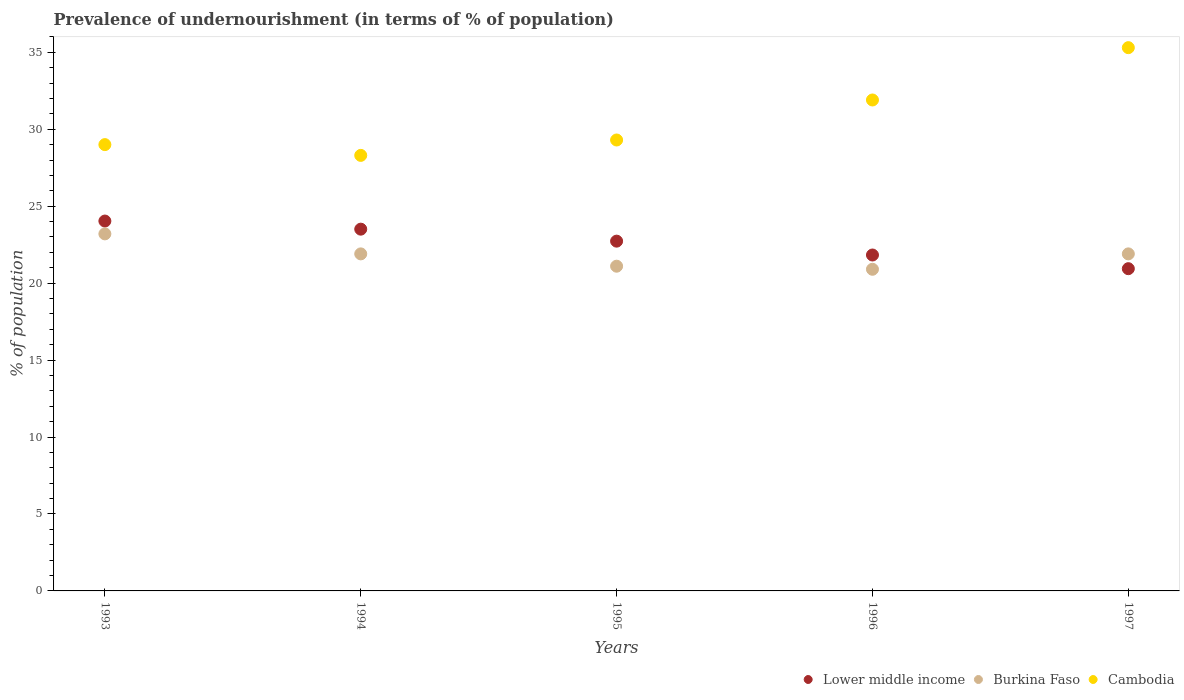Is the number of dotlines equal to the number of legend labels?
Your response must be concise. Yes. What is the percentage of undernourished population in Cambodia in 1995?
Offer a terse response. 29.3. Across all years, what is the maximum percentage of undernourished population in Burkina Faso?
Provide a short and direct response. 23.2. Across all years, what is the minimum percentage of undernourished population in Cambodia?
Keep it short and to the point. 28.3. In which year was the percentage of undernourished population in Cambodia maximum?
Give a very brief answer. 1997. In which year was the percentage of undernourished population in Lower middle income minimum?
Offer a terse response. 1997. What is the total percentage of undernourished population in Burkina Faso in the graph?
Provide a succinct answer. 109. What is the difference between the percentage of undernourished population in Burkina Faso in 1993 and that in 1996?
Ensure brevity in your answer.  2.3. What is the difference between the percentage of undernourished population in Burkina Faso in 1995 and the percentage of undernourished population in Lower middle income in 1996?
Your answer should be very brief. -0.73. What is the average percentage of undernourished population in Cambodia per year?
Give a very brief answer. 30.76. In the year 1995, what is the difference between the percentage of undernourished population in Cambodia and percentage of undernourished population in Lower middle income?
Keep it short and to the point. 6.57. What is the ratio of the percentage of undernourished population in Burkina Faso in 1994 to that in 1997?
Your response must be concise. 1. Is the percentage of undernourished population in Lower middle income in 1994 less than that in 1995?
Offer a very short reply. No. Is the difference between the percentage of undernourished population in Cambodia in 1993 and 1996 greater than the difference between the percentage of undernourished population in Lower middle income in 1993 and 1996?
Offer a very short reply. No. What is the difference between the highest and the second highest percentage of undernourished population in Burkina Faso?
Give a very brief answer. 1.3. What is the difference between the highest and the lowest percentage of undernourished population in Lower middle income?
Offer a very short reply. 3.1. In how many years, is the percentage of undernourished population in Burkina Faso greater than the average percentage of undernourished population in Burkina Faso taken over all years?
Provide a succinct answer. 3. Is it the case that in every year, the sum of the percentage of undernourished population in Burkina Faso and percentage of undernourished population in Lower middle income  is greater than the percentage of undernourished population in Cambodia?
Keep it short and to the point. Yes. Does the percentage of undernourished population in Lower middle income monotonically increase over the years?
Your answer should be compact. No. How many years are there in the graph?
Make the answer very short. 5. What is the difference between two consecutive major ticks on the Y-axis?
Your answer should be compact. 5. Does the graph contain grids?
Offer a very short reply. No. How are the legend labels stacked?
Keep it short and to the point. Horizontal. What is the title of the graph?
Keep it short and to the point. Prevalence of undernourishment (in terms of % of population). Does "Cambodia" appear as one of the legend labels in the graph?
Your answer should be very brief. Yes. What is the label or title of the Y-axis?
Make the answer very short. % of population. What is the % of population of Lower middle income in 1993?
Your answer should be compact. 24.03. What is the % of population in Burkina Faso in 1993?
Ensure brevity in your answer.  23.2. What is the % of population in Lower middle income in 1994?
Offer a terse response. 23.51. What is the % of population of Burkina Faso in 1994?
Offer a terse response. 21.9. What is the % of population of Cambodia in 1994?
Your response must be concise. 28.3. What is the % of population of Lower middle income in 1995?
Provide a succinct answer. 22.73. What is the % of population of Burkina Faso in 1995?
Provide a succinct answer. 21.1. What is the % of population of Cambodia in 1995?
Keep it short and to the point. 29.3. What is the % of population of Lower middle income in 1996?
Your answer should be compact. 21.83. What is the % of population in Burkina Faso in 1996?
Offer a terse response. 20.9. What is the % of population in Cambodia in 1996?
Your answer should be compact. 31.9. What is the % of population in Lower middle income in 1997?
Offer a very short reply. 20.94. What is the % of population of Burkina Faso in 1997?
Your response must be concise. 21.9. What is the % of population of Cambodia in 1997?
Provide a short and direct response. 35.3. Across all years, what is the maximum % of population in Lower middle income?
Offer a very short reply. 24.03. Across all years, what is the maximum % of population in Burkina Faso?
Provide a short and direct response. 23.2. Across all years, what is the maximum % of population of Cambodia?
Offer a very short reply. 35.3. Across all years, what is the minimum % of population in Lower middle income?
Your answer should be compact. 20.94. Across all years, what is the minimum % of population of Burkina Faso?
Keep it short and to the point. 20.9. Across all years, what is the minimum % of population in Cambodia?
Give a very brief answer. 28.3. What is the total % of population in Lower middle income in the graph?
Your answer should be compact. 113.03. What is the total % of population of Burkina Faso in the graph?
Your answer should be very brief. 109. What is the total % of population of Cambodia in the graph?
Provide a succinct answer. 153.8. What is the difference between the % of population in Lower middle income in 1993 and that in 1994?
Provide a succinct answer. 0.53. What is the difference between the % of population in Burkina Faso in 1993 and that in 1994?
Provide a short and direct response. 1.3. What is the difference between the % of population of Lower middle income in 1993 and that in 1995?
Provide a short and direct response. 1.31. What is the difference between the % of population in Burkina Faso in 1993 and that in 1995?
Your answer should be very brief. 2.1. What is the difference between the % of population in Cambodia in 1993 and that in 1995?
Provide a short and direct response. -0.3. What is the difference between the % of population of Lower middle income in 1993 and that in 1996?
Give a very brief answer. 2.21. What is the difference between the % of population of Lower middle income in 1993 and that in 1997?
Make the answer very short. 3.1. What is the difference between the % of population of Burkina Faso in 1993 and that in 1997?
Ensure brevity in your answer.  1.3. What is the difference between the % of population of Lower middle income in 1994 and that in 1995?
Offer a very short reply. 0.78. What is the difference between the % of population of Cambodia in 1994 and that in 1995?
Provide a succinct answer. -1. What is the difference between the % of population of Lower middle income in 1994 and that in 1996?
Provide a succinct answer. 1.68. What is the difference between the % of population in Cambodia in 1994 and that in 1996?
Keep it short and to the point. -3.6. What is the difference between the % of population in Lower middle income in 1994 and that in 1997?
Offer a very short reply. 2.57. What is the difference between the % of population in Cambodia in 1994 and that in 1997?
Give a very brief answer. -7. What is the difference between the % of population in Lower middle income in 1995 and that in 1996?
Keep it short and to the point. 0.9. What is the difference between the % of population of Burkina Faso in 1995 and that in 1996?
Keep it short and to the point. 0.2. What is the difference between the % of population of Lower middle income in 1995 and that in 1997?
Keep it short and to the point. 1.79. What is the difference between the % of population of Lower middle income in 1996 and that in 1997?
Your answer should be compact. 0.89. What is the difference between the % of population in Lower middle income in 1993 and the % of population in Burkina Faso in 1994?
Your answer should be very brief. 2.13. What is the difference between the % of population in Lower middle income in 1993 and the % of population in Cambodia in 1994?
Keep it short and to the point. -4.27. What is the difference between the % of population in Burkina Faso in 1993 and the % of population in Cambodia in 1994?
Offer a very short reply. -5.1. What is the difference between the % of population of Lower middle income in 1993 and the % of population of Burkina Faso in 1995?
Keep it short and to the point. 2.93. What is the difference between the % of population of Lower middle income in 1993 and the % of population of Cambodia in 1995?
Make the answer very short. -5.27. What is the difference between the % of population of Burkina Faso in 1993 and the % of population of Cambodia in 1995?
Give a very brief answer. -6.1. What is the difference between the % of population in Lower middle income in 1993 and the % of population in Burkina Faso in 1996?
Ensure brevity in your answer.  3.13. What is the difference between the % of population in Lower middle income in 1993 and the % of population in Cambodia in 1996?
Your answer should be very brief. -7.87. What is the difference between the % of population in Lower middle income in 1993 and the % of population in Burkina Faso in 1997?
Provide a short and direct response. 2.13. What is the difference between the % of population of Lower middle income in 1993 and the % of population of Cambodia in 1997?
Your answer should be very brief. -11.27. What is the difference between the % of population of Burkina Faso in 1993 and the % of population of Cambodia in 1997?
Provide a succinct answer. -12.1. What is the difference between the % of population of Lower middle income in 1994 and the % of population of Burkina Faso in 1995?
Your answer should be very brief. 2.41. What is the difference between the % of population in Lower middle income in 1994 and the % of population in Cambodia in 1995?
Give a very brief answer. -5.79. What is the difference between the % of population in Burkina Faso in 1994 and the % of population in Cambodia in 1995?
Ensure brevity in your answer.  -7.4. What is the difference between the % of population in Lower middle income in 1994 and the % of population in Burkina Faso in 1996?
Your response must be concise. 2.61. What is the difference between the % of population in Lower middle income in 1994 and the % of population in Cambodia in 1996?
Make the answer very short. -8.39. What is the difference between the % of population in Burkina Faso in 1994 and the % of population in Cambodia in 1996?
Ensure brevity in your answer.  -10. What is the difference between the % of population in Lower middle income in 1994 and the % of population in Burkina Faso in 1997?
Provide a short and direct response. 1.61. What is the difference between the % of population in Lower middle income in 1994 and the % of population in Cambodia in 1997?
Your response must be concise. -11.79. What is the difference between the % of population in Lower middle income in 1995 and the % of population in Burkina Faso in 1996?
Your answer should be compact. 1.83. What is the difference between the % of population in Lower middle income in 1995 and the % of population in Cambodia in 1996?
Offer a very short reply. -9.17. What is the difference between the % of population in Burkina Faso in 1995 and the % of population in Cambodia in 1996?
Offer a very short reply. -10.8. What is the difference between the % of population of Lower middle income in 1995 and the % of population of Burkina Faso in 1997?
Your answer should be compact. 0.83. What is the difference between the % of population in Lower middle income in 1995 and the % of population in Cambodia in 1997?
Keep it short and to the point. -12.57. What is the difference between the % of population of Lower middle income in 1996 and the % of population of Burkina Faso in 1997?
Make the answer very short. -0.07. What is the difference between the % of population in Lower middle income in 1996 and the % of population in Cambodia in 1997?
Offer a terse response. -13.47. What is the difference between the % of population in Burkina Faso in 1996 and the % of population in Cambodia in 1997?
Provide a short and direct response. -14.4. What is the average % of population in Lower middle income per year?
Make the answer very short. 22.61. What is the average % of population of Burkina Faso per year?
Give a very brief answer. 21.8. What is the average % of population of Cambodia per year?
Offer a terse response. 30.76. In the year 1993, what is the difference between the % of population in Lower middle income and % of population in Burkina Faso?
Provide a succinct answer. 0.83. In the year 1993, what is the difference between the % of population of Lower middle income and % of population of Cambodia?
Make the answer very short. -4.97. In the year 1994, what is the difference between the % of population in Lower middle income and % of population in Burkina Faso?
Keep it short and to the point. 1.61. In the year 1994, what is the difference between the % of population in Lower middle income and % of population in Cambodia?
Offer a very short reply. -4.79. In the year 1994, what is the difference between the % of population of Burkina Faso and % of population of Cambodia?
Keep it short and to the point. -6.4. In the year 1995, what is the difference between the % of population in Lower middle income and % of population in Burkina Faso?
Your answer should be very brief. 1.63. In the year 1995, what is the difference between the % of population in Lower middle income and % of population in Cambodia?
Give a very brief answer. -6.57. In the year 1995, what is the difference between the % of population in Burkina Faso and % of population in Cambodia?
Your answer should be very brief. -8.2. In the year 1996, what is the difference between the % of population in Lower middle income and % of population in Burkina Faso?
Keep it short and to the point. 0.93. In the year 1996, what is the difference between the % of population in Lower middle income and % of population in Cambodia?
Offer a terse response. -10.07. In the year 1996, what is the difference between the % of population in Burkina Faso and % of population in Cambodia?
Ensure brevity in your answer.  -11. In the year 1997, what is the difference between the % of population in Lower middle income and % of population in Burkina Faso?
Keep it short and to the point. -0.96. In the year 1997, what is the difference between the % of population in Lower middle income and % of population in Cambodia?
Offer a terse response. -14.36. What is the ratio of the % of population of Lower middle income in 1993 to that in 1994?
Provide a succinct answer. 1.02. What is the ratio of the % of population in Burkina Faso in 1993 to that in 1994?
Your response must be concise. 1.06. What is the ratio of the % of population in Cambodia in 1993 to that in 1994?
Your answer should be compact. 1.02. What is the ratio of the % of population of Lower middle income in 1993 to that in 1995?
Provide a short and direct response. 1.06. What is the ratio of the % of population of Burkina Faso in 1993 to that in 1995?
Ensure brevity in your answer.  1.1. What is the ratio of the % of population of Cambodia in 1993 to that in 1995?
Ensure brevity in your answer.  0.99. What is the ratio of the % of population of Lower middle income in 1993 to that in 1996?
Provide a short and direct response. 1.1. What is the ratio of the % of population of Burkina Faso in 1993 to that in 1996?
Keep it short and to the point. 1.11. What is the ratio of the % of population of Cambodia in 1993 to that in 1996?
Provide a short and direct response. 0.91. What is the ratio of the % of population of Lower middle income in 1993 to that in 1997?
Make the answer very short. 1.15. What is the ratio of the % of population in Burkina Faso in 1993 to that in 1997?
Offer a very short reply. 1.06. What is the ratio of the % of population of Cambodia in 1993 to that in 1997?
Give a very brief answer. 0.82. What is the ratio of the % of population in Lower middle income in 1994 to that in 1995?
Keep it short and to the point. 1.03. What is the ratio of the % of population in Burkina Faso in 1994 to that in 1995?
Provide a short and direct response. 1.04. What is the ratio of the % of population in Cambodia in 1994 to that in 1995?
Provide a succinct answer. 0.97. What is the ratio of the % of population of Lower middle income in 1994 to that in 1996?
Your response must be concise. 1.08. What is the ratio of the % of population in Burkina Faso in 1994 to that in 1996?
Offer a very short reply. 1.05. What is the ratio of the % of population in Cambodia in 1994 to that in 1996?
Ensure brevity in your answer.  0.89. What is the ratio of the % of population of Lower middle income in 1994 to that in 1997?
Your answer should be compact. 1.12. What is the ratio of the % of population of Cambodia in 1994 to that in 1997?
Offer a very short reply. 0.8. What is the ratio of the % of population of Lower middle income in 1995 to that in 1996?
Give a very brief answer. 1.04. What is the ratio of the % of population in Burkina Faso in 1995 to that in 1996?
Offer a very short reply. 1.01. What is the ratio of the % of population in Cambodia in 1995 to that in 1996?
Offer a terse response. 0.92. What is the ratio of the % of population of Lower middle income in 1995 to that in 1997?
Your answer should be compact. 1.09. What is the ratio of the % of population of Burkina Faso in 1995 to that in 1997?
Give a very brief answer. 0.96. What is the ratio of the % of population in Cambodia in 1995 to that in 1997?
Offer a terse response. 0.83. What is the ratio of the % of population in Lower middle income in 1996 to that in 1997?
Ensure brevity in your answer.  1.04. What is the ratio of the % of population of Burkina Faso in 1996 to that in 1997?
Provide a short and direct response. 0.95. What is the ratio of the % of population of Cambodia in 1996 to that in 1997?
Give a very brief answer. 0.9. What is the difference between the highest and the second highest % of population in Lower middle income?
Provide a succinct answer. 0.53. What is the difference between the highest and the second highest % of population in Burkina Faso?
Offer a very short reply. 1.3. What is the difference between the highest and the lowest % of population in Lower middle income?
Your answer should be very brief. 3.1. 